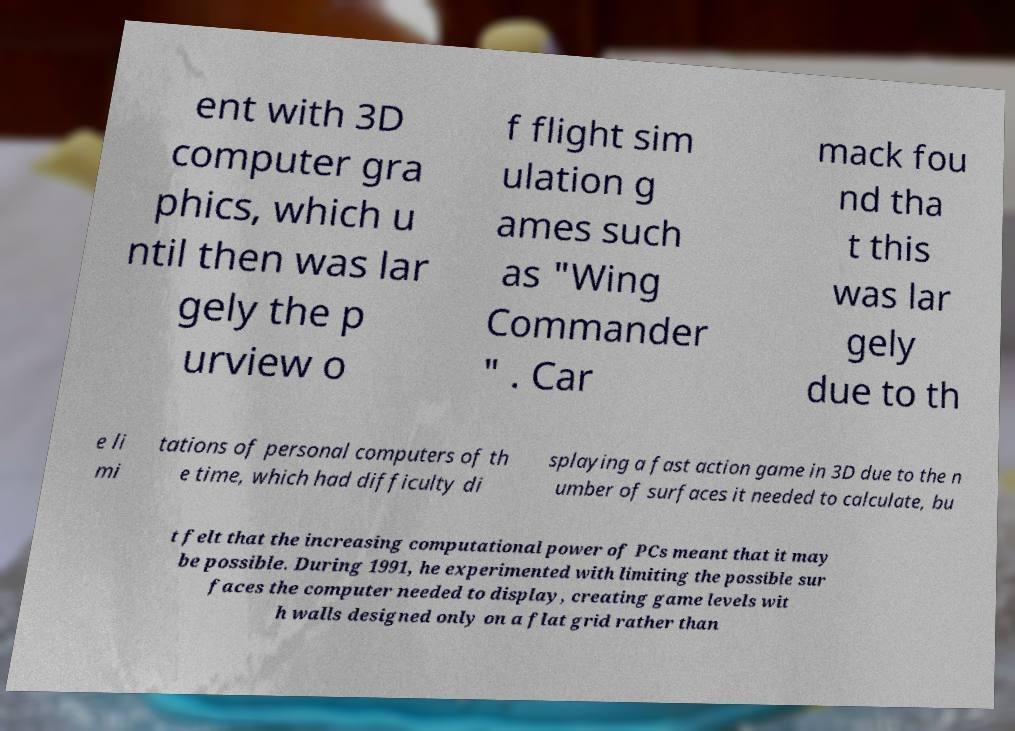I need the written content from this picture converted into text. Can you do that? ent with 3D computer gra phics, which u ntil then was lar gely the p urview o f flight sim ulation g ames such as "Wing Commander " . Car mack fou nd tha t this was lar gely due to th e li mi tations of personal computers of th e time, which had difficulty di splaying a fast action game in 3D due to the n umber of surfaces it needed to calculate, bu t felt that the increasing computational power of PCs meant that it may be possible. During 1991, he experimented with limiting the possible sur faces the computer needed to display, creating game levels wit h walls designed only on a flat grid rather than 